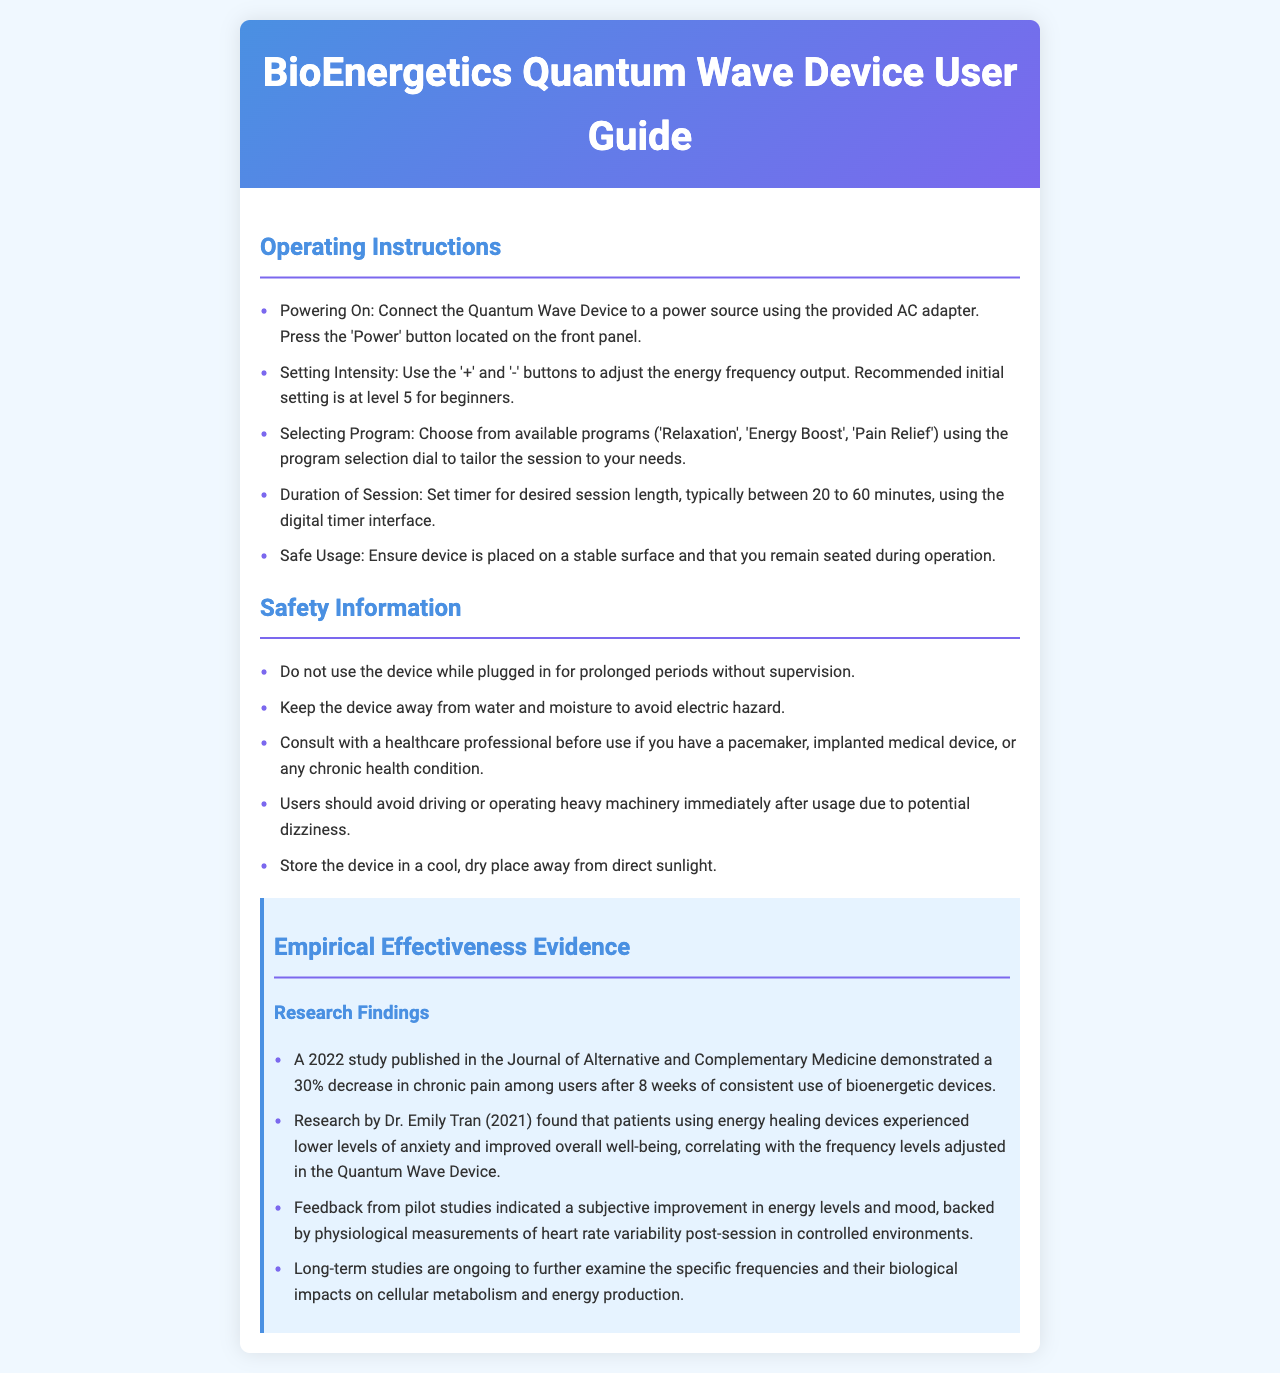what is the initial recommended setting for beginners? The document specifies that the recommended initial setting for beginners is at level 5.
Answer: level 5 how many programs are available on the device? According to the operating instructions, there are three programs: 'Relaxation', 'Energy Boost', and 'Pain Relief'.
Answer: three what should users avoid doing immediately after using the device? The safety information warns users to avoid driving or operating heavy machinery immediately after usage due to potential dizziness.
Answer: driving or operating heavy machinery what is the maximum duration recommended for a session? The document states that the typical duration of a session is between 20 to 60 minutes.
Answer: 60 minutes which publication reported a study on chronic pain decrease due to device usage? The document mentions a 2022 study published in the Journal of Alternative and Complementary Medicine that demonstrated a decrease in chronic pain.
Answer: Journal of Alternative and Complementary Medicine what is one of the physiological measures mentioned that supports user feedback? Feedback from pilot studies includes physiological measurements of heart rate variability post-session.
Answer: heart rate variability who conducted research related to anxiety levels and energy healing devices? The document cites research by Dr. Emily Tran in 2021 that found patients using energy healing devices experienced lower levels of anxiety.
Answer: Dr. Emily Tran what is a safety precaution regarding device usage in moist environments? The safety information instructs users to keep the device away from water and moisture to avoid electric hazard.
Answer: away from water and moisture 